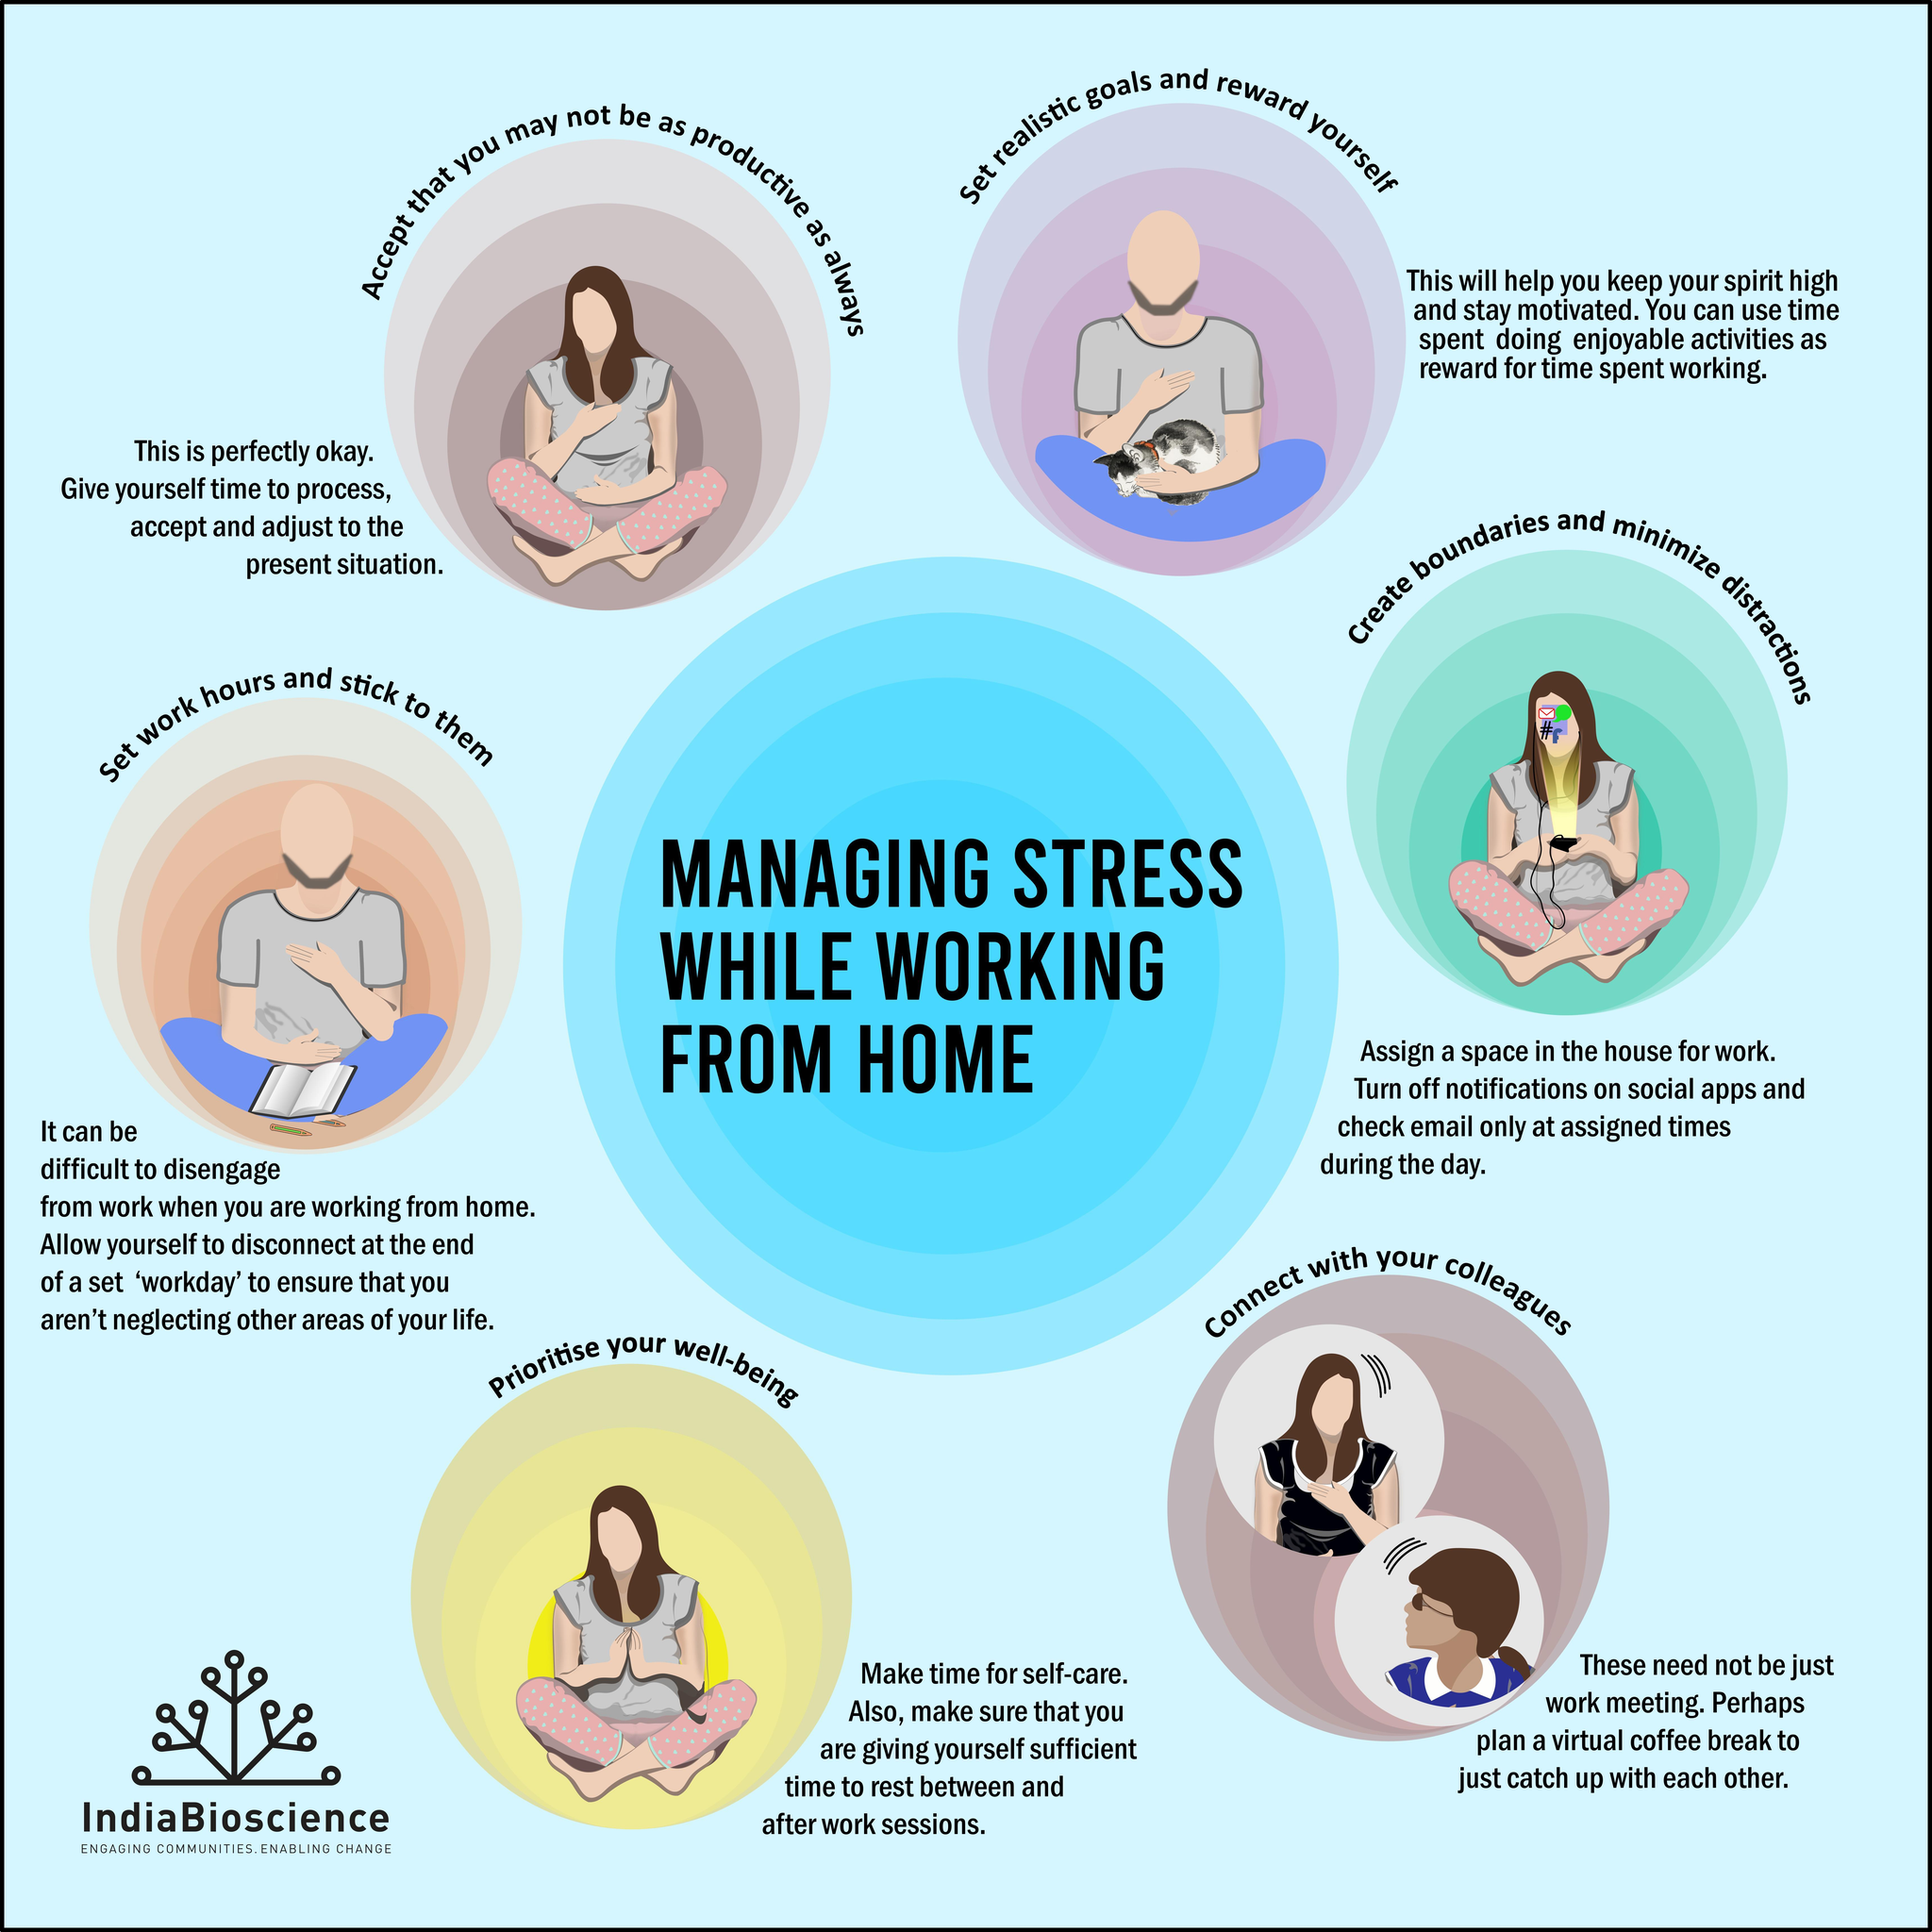How many ways stress managed while working from home?
Answer the question with a short phrase. 6 